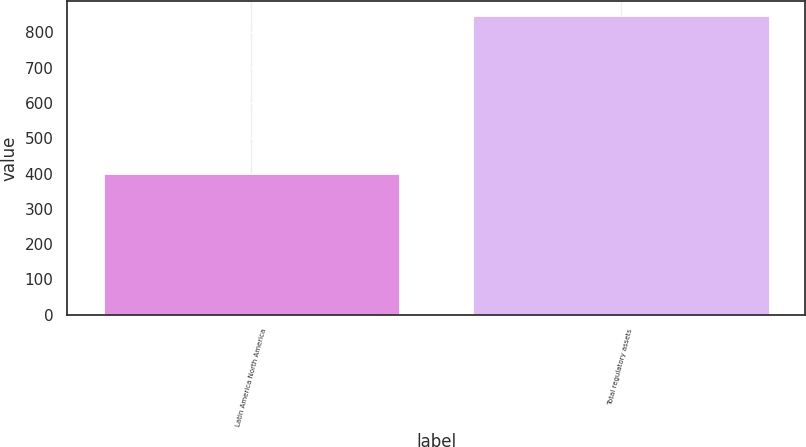<chart> <loc_0><loc_0><loc_500><loc_500><bar_chart><fcel>Latin America North America<fcel>Total regulatory assets<nl><fcel>400<fcel>845<nl></chart> 